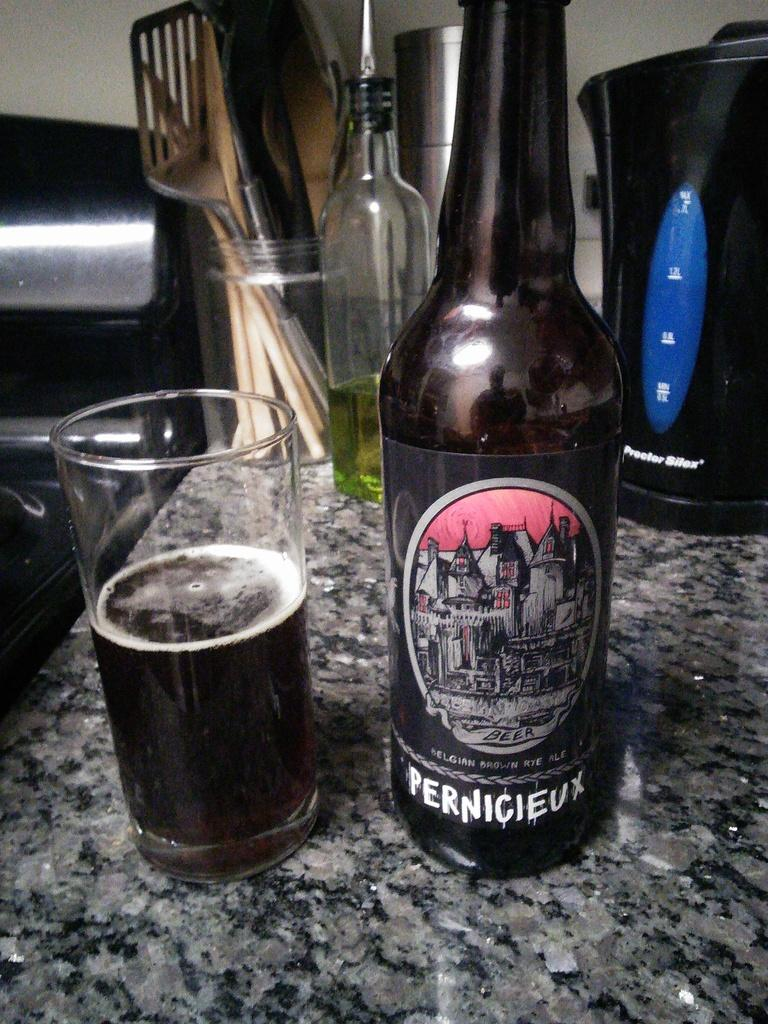<image>
Give a short and clear explanation of the subsequent image. A half full glass is on the counter next to an open bottle of Pernicieux. 